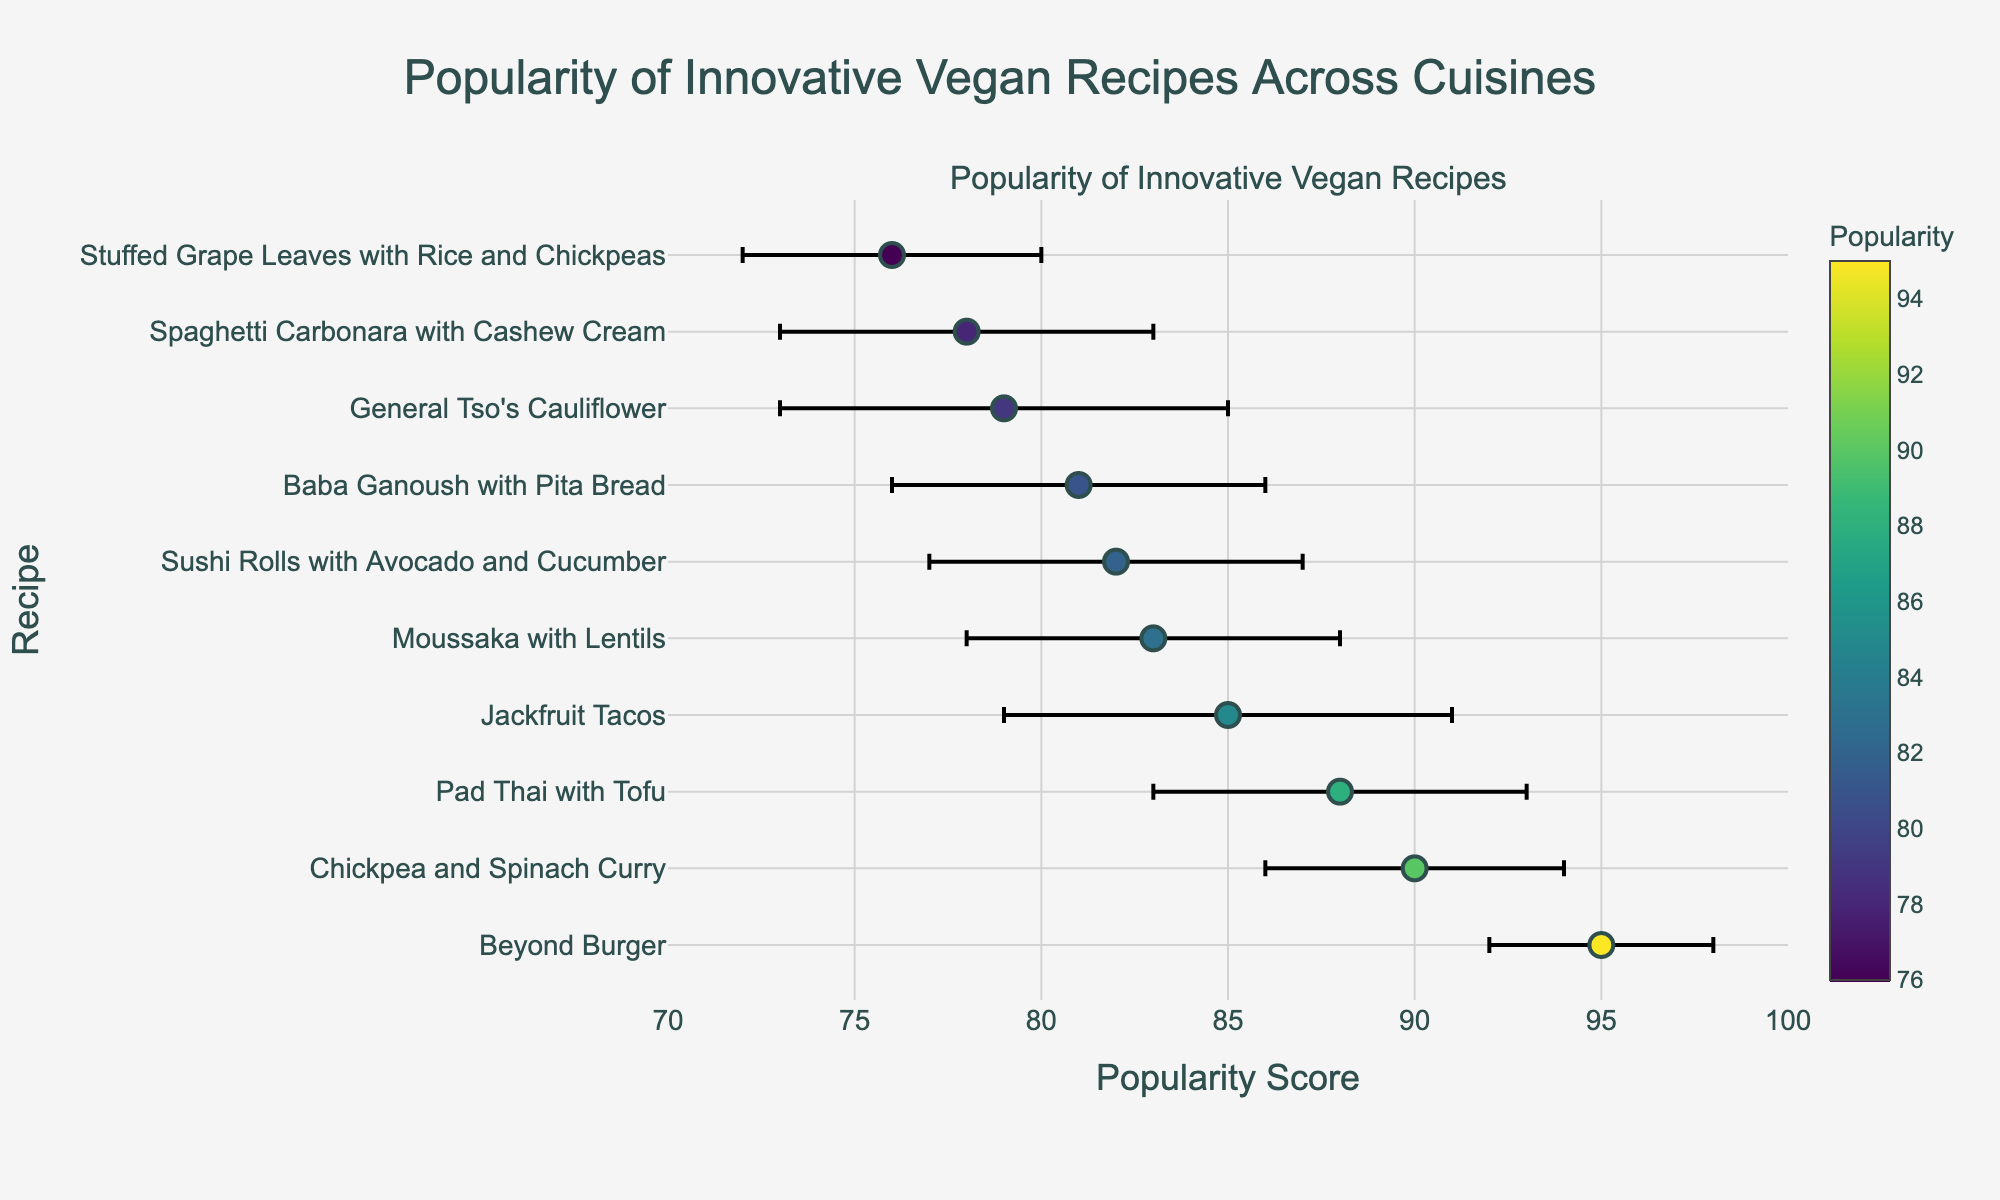What is the title of the figure? The title is usually displayed at the top of the figure. It provides an overview of the content being presented in the plot. In this case, the title is "Popularity of Innovative Vegan Recipes Across Cuisines".
Answer: "Popularity of Innovative Vegan Recipes Across Cuisines" Which cuisine's vegan recipe has the highest popularity? Look for the dot that is positioned furthest to the right on the x-axis, as it represents the highest popularity score. The corresponding y-axis label will indicate the cuisine.
Answer: American (Beyond Burger) How many recipes have a popularity score above 85? Count the number of dots positioned to the right of the vertical line at the score of 85 on the x-axis. These represent the recipes with popularity scores above 85.
Answer: 3 Which vegan recipe has the largest spread (error bar width)? Identify the dot with the longest horizontal error bar. The recipe corresponding to this dot will have the largest standard error.
Answer: General Tso's Cauliflower What is the popularity score of the least popular recipe? Find the dot that is positioned furthest to the left on the x-axis. The x-coordinate of this dot is the popularity score of the least popular recipe.
Answer: 76 (Stuffed Grape Leaves with Rice and Chickpeas) Which cuisine's recipe has a popularity score most similar to "Pad Thai with Tofu"? Locate the dot for "Pad Thai with Tofu" and find another dot that is closest to it along the x-axis. Compare their scores to confirm the similarity.
Answer: Greek (Moussaka with Lentils) What is the average popularity score of the recipes in the figure? Sum the popularity scores of all the recipes and divide by the total number of recipes. The popularity scores are 78, 85, 90, 82, 76, 88, 81, 95, 79, 83. The sum is 837, and there are 10 recipes. So, 837 / 10 = 83.7
Answer: 83.7 How many cuisines have recipes with a popularity score between 80 and 90? Count the number of dots that fall within the range of 80 to 90 on the x-axis. These dots represent the recipes with scores within that range.
Answer: 6 What is the difference in popularity between the most popular and the least popular recipe? Find the popularity score of the most popular recipe (95) and the least popular recipe (76). Subtract the least popular score from the most popular score: 95 - 76 = 19.
Answer: 19 